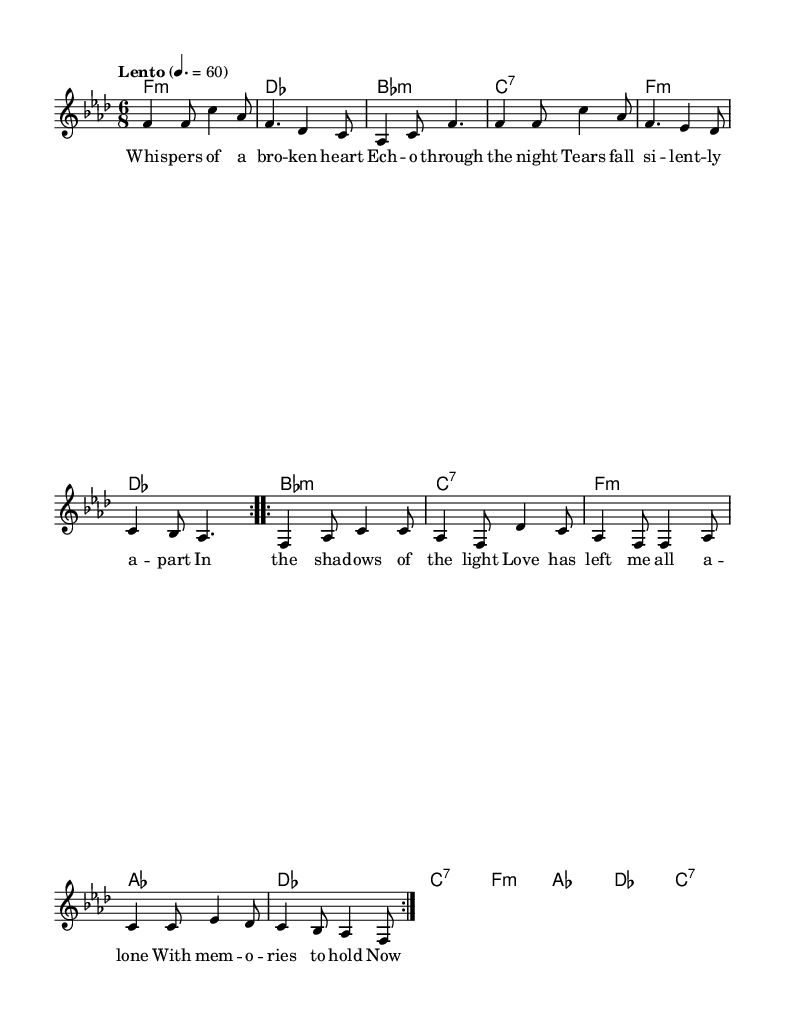What is the key signature of this music? The key signature is indicated at the beginning of the staff. In this case, it shows four flats which represent F minor.
Answer: F minor What is the time signature of this music? The time signature is displayed at the beginning of the score, where it is written as a fraction. Here, it is 6 over 8, indicating a compound time signature with six eighth-note beats per measure.
Answer: 6/8 What is the tempo marking of this music? The tempo marking is found above the staff, stating the speed at which the piece should be played. It indicates "Lento," which typically means slow. It is further specified with a metronome marking of 60 beats per minute.
Answer: Lento How many measures are in the verse section? To find this, I can count the distinct measures indicated in the melody section under "Verse." There are eight measures repeated twice, making it a total of sixteen.
Answer: 16 What type of chord progression is used in the verse? Reviewing the chord symbols beneath the melody shows a pattern of minor and seventh chords typically associated with emotional depth, common in soul music. The progression alternates between four distinct chords.
Answer: Minor and seventh chords What is the most prominent theme conveyed in the lyrics? An analysis of the lyrics suggests that themes of heartbreak and loneliness are evident as the singer expresses feelings of being lost and alone after a relationship ends. This aligns with typical soul themes.
Answer: Heartbreak Which melodic interval stands out in the chorus? Looking at the distances between the notes in the chorus, one might note the frequent use of thirds and sixths which contribute to the characteristic sound of soul music. Particularly, the leap from F to C creates a highlighted range.
Answer: Thirds and sixths 